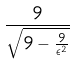<formula> <loc_0><loc_0><loc_500><loc_500>\frac { 9 } { \sqrt { 9 - \frac { 9 } { \epsilon ^ { 2 } } } }</formula> 